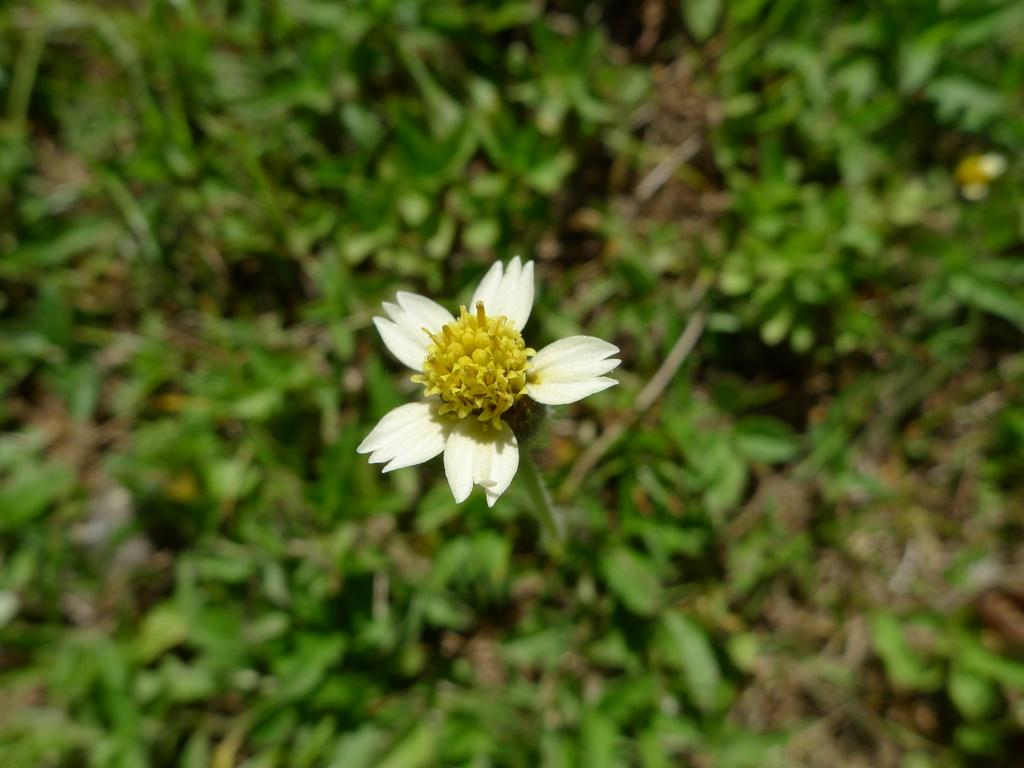What is the main subject of the image? There is a flower in the center of the image. What type of vegetation can be seen in the background of the image? There is grass visible in the background of the image. Can you tell me how many kitties are playing with the cactus in the image? There are no kitties or cactus present in the image; it features a flower and grass. 